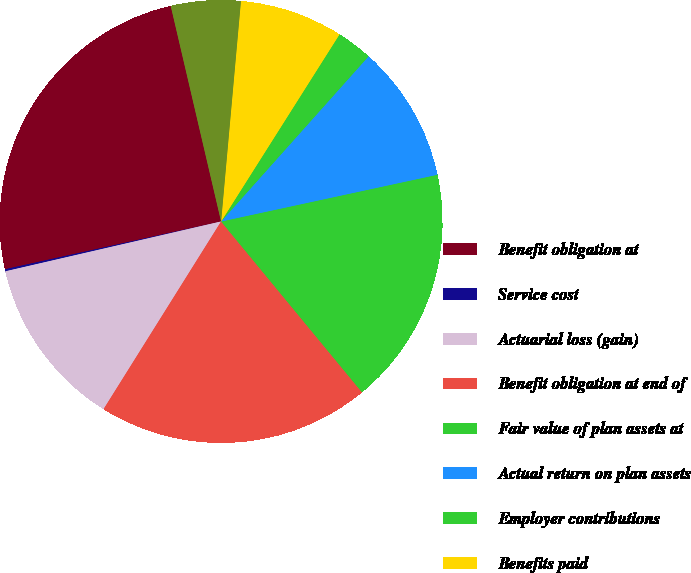Convert chart. <chart><loc_0><loc_0><loc_500><loc_500><pie_chart><fcel>Benefit obligation at<fcel>Service cost<fcel>Actuarial loss (gain)<fcel>Benefit obligation at end of<fcel>Fair value of plan assets at<fcel>Actual return on plan assets<fcel>Employer contributions<fcel>Benefits paid<fcel>Funded status - underfunded<nl><fcel>24.81%<fcel>0.15%<fcel>12.48%<fcel>19.88%<fcel>17.41%<fcel>10.01%<fcel>2.62%<fcel>7.55%<fcel>5.08%<nl></chart> 